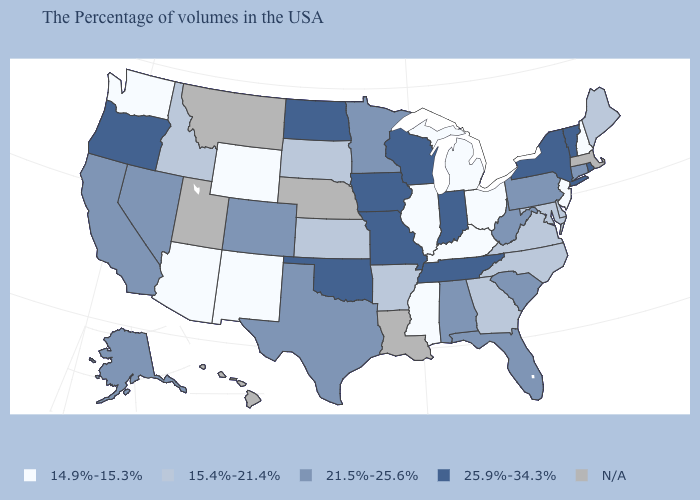What is the value of Vermont?
Be succinct. 25.9%-34.3%. What is the value of West Virginia?
Write a very short answer. 21.5%-25.6%. What is the highest value in the USA?
Give a very brief answer. 25.9%-34.3%. Name the states that have a value in the range N/A?
Keep it brief. Massachusetts, Louisiana, Nebraska, Utah, Montana, Hawaii. Does Maine have the highest value in the Northeast?
Give a very brief answer. No. Which states have the lowest value in the West?
Concise answer only. Wyoming, New Mexico, Arizona, Washington. Does the map have missing data?
Answer briefly. Yes. What is the lowest value in states that border Virginia?
Keep it brief. 14.9%-15.3%. Does Arizona have the highest value in the West?
Write a very short answer. No. What is the value of Iowa?
Short answer required. 25.9%-34.3%. What is the value of Georgia?
Concise answer only. 15.4%-21.4%. Which states have the lowest value in the USA?
Answer briefly. New Hampshire, New Jersey, Ohio, Michigan, Kentucky, Illinois, Mississippi, Wyoming, New Mexico, Arizona, Washington. What is the value of Connecticut?
Write a very short answer. 21.5%-25.6%. Does Minnesota have the highest value in the MidWest?
Answer briefly. No. 